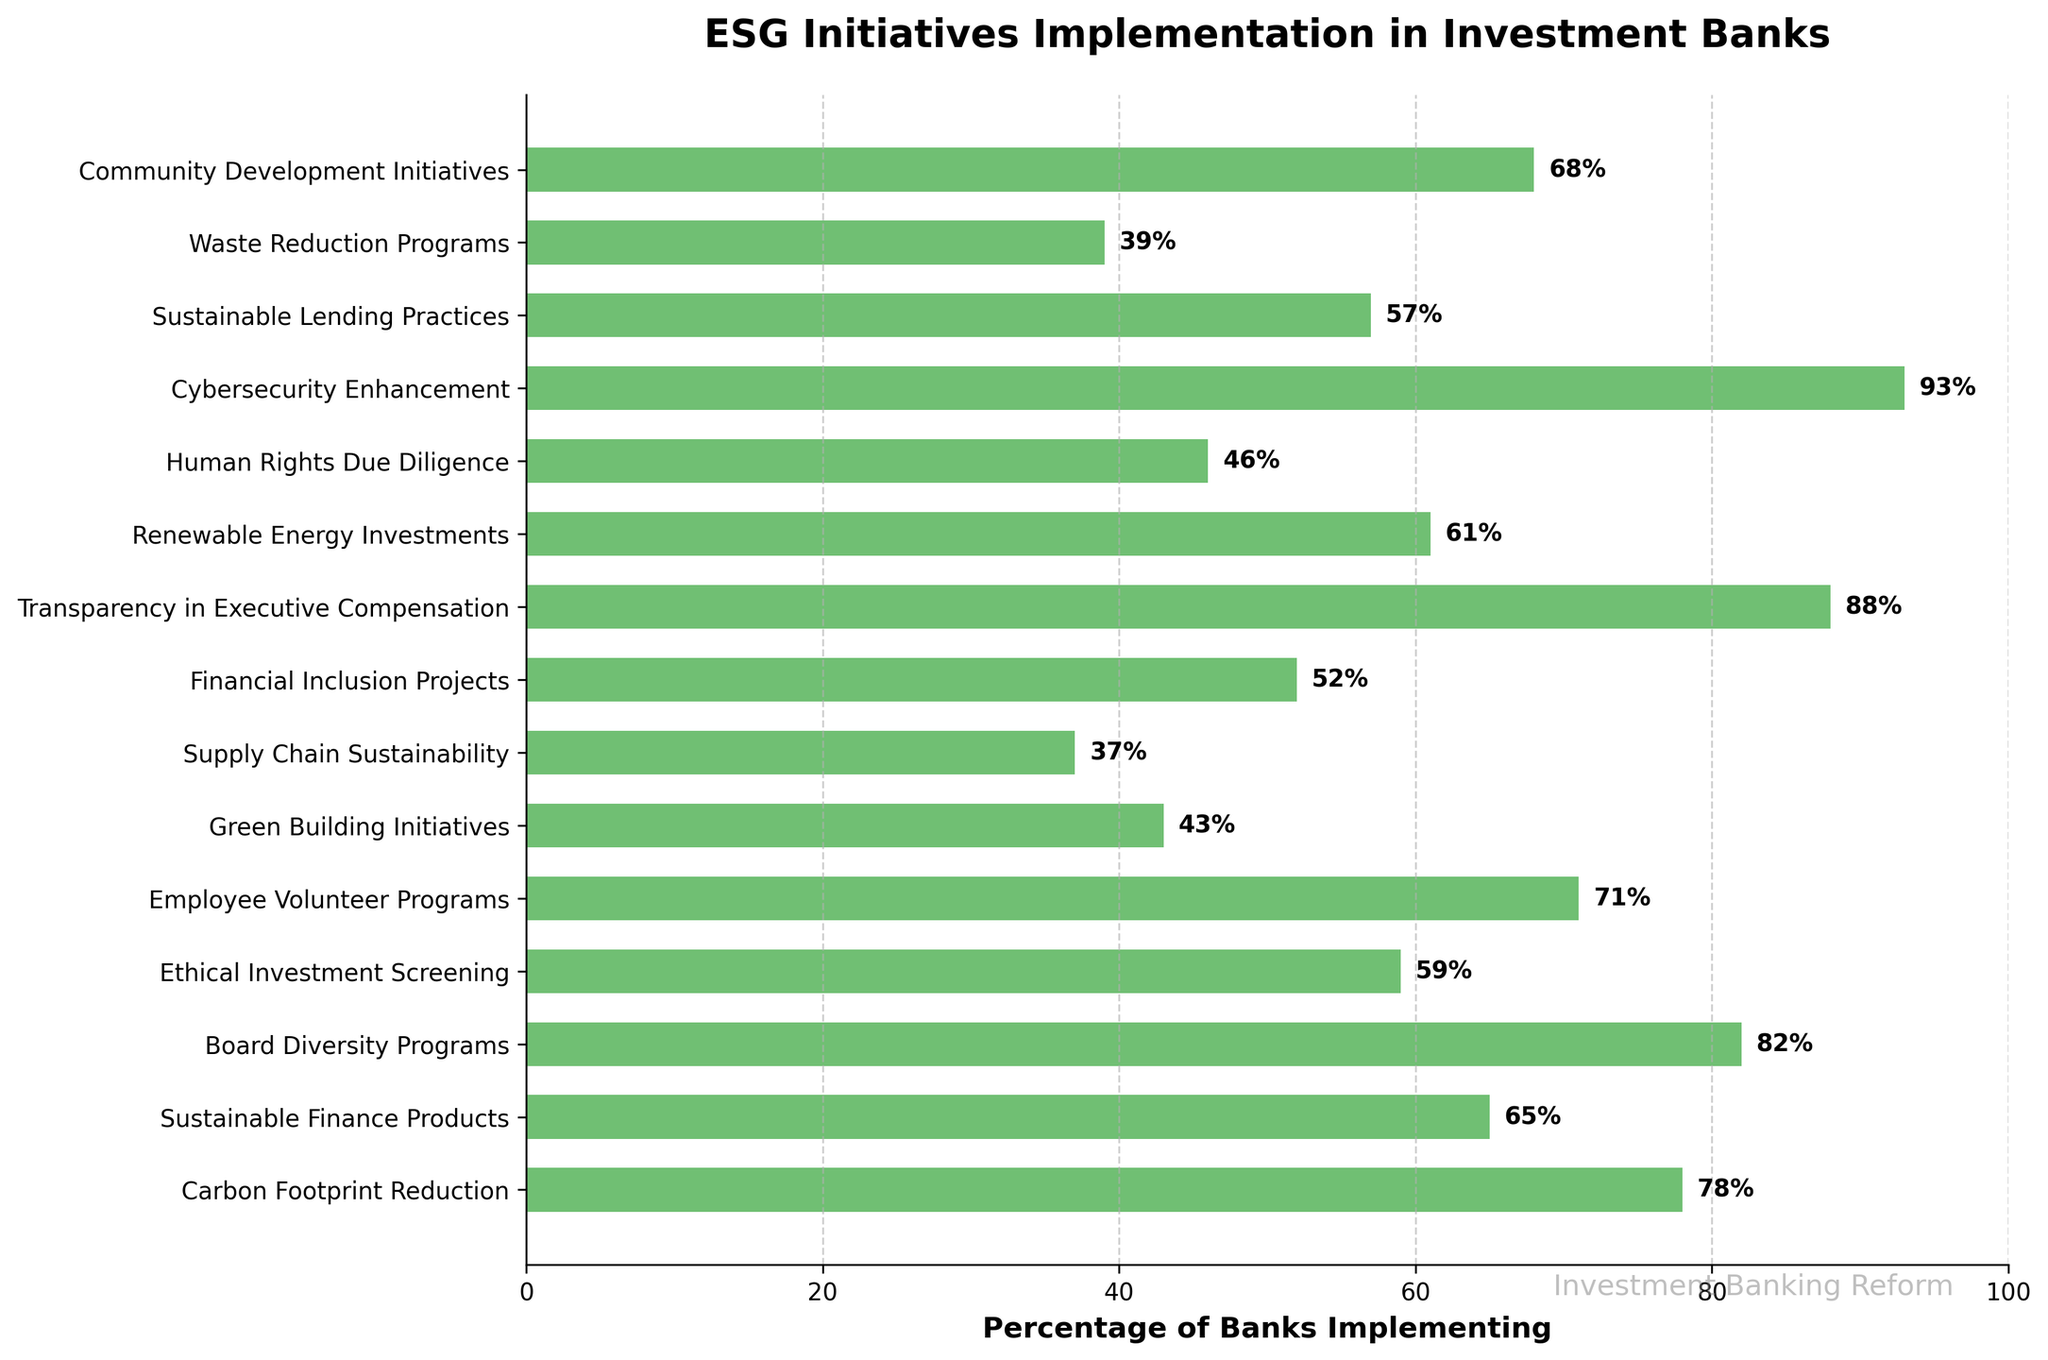What is the percentage of banks implementing Cybersecurity Enhancement? Observing the bar associated with Cybersecurity Enhancement shows the length reaching 93%.
Answer: 93% Which ESG initiative has the highest implementation percentage? By comparing the lengths of all bars, Transparency in Executive Compensation has the longest bar with 88%.
Answer: Transparency in Executive Compensation What is the difference between the percentage of banks implementing Carbon Footprint Reduction and Sustainable Finance Products? The lengths of bars for Carbon Footprint Reduction and Sustainable Finance Products are 78% and 65%, respectively. The difference is 78% - 65% = 13%.
Answer: 13% What is the average percentage of banks implementing the top three ESG initiatives? The top three initiatives by implementation are Cybersecurity Enhancement (93%), Board Diversity Programs (82%), and Transparency in Executive Compensation (88%). The average is (93 + 82 + 88) / 3 = 87.67%.
Answer: 87.67% Which ESG initiative related to social factors has the lowest percentage of implementation? Among the social-related initiatives, Financial Inclusion Projects (52%), Employee Volunteer Programs (71%), Community Development Initiatives (68%), and Human Rights Due Diligence (46%), the lowest is Human Rights Due Diligence with 46%.
Answer: Human Rights Due Diligence How many ESG initiatives have an implementation percentage below 50%? By scanning the chart, we see Green Building Initiatives (43%), Supply Chain Sustainability (37%), Human Rights Due Diligence (46%), and Waste Reduction Programs (39%) are below 50%. There are 4 such initiatives.
Answer: 4 What is the percentage difference between the highest and lowest implementing ESG initiatives? The highest percentage is Cybersecurity Enhancement (93%) and the lowest is Supply Chain Sustainability (37%). The difference is 93% - 37% = 56%.
Answer: 56% Which ESG initiative aims at executive policies and has the highest implementation rate? The initiatives related to executive policies are Transparency in Executive Compensation (88%) and Board Diversity Programs (82%). The highest rate is Transparency in Executive Compensation with 88%.
Answer: Transparency in Executive Compensation What is the sum of the implementation percentages of Community Development Initiatives and Waste Reduction Programs? Community Development Initiatives is 68% and Waste Reduction Programs is 39%. Their sum is 68% + 39% = 107%.
Answer: 107% 